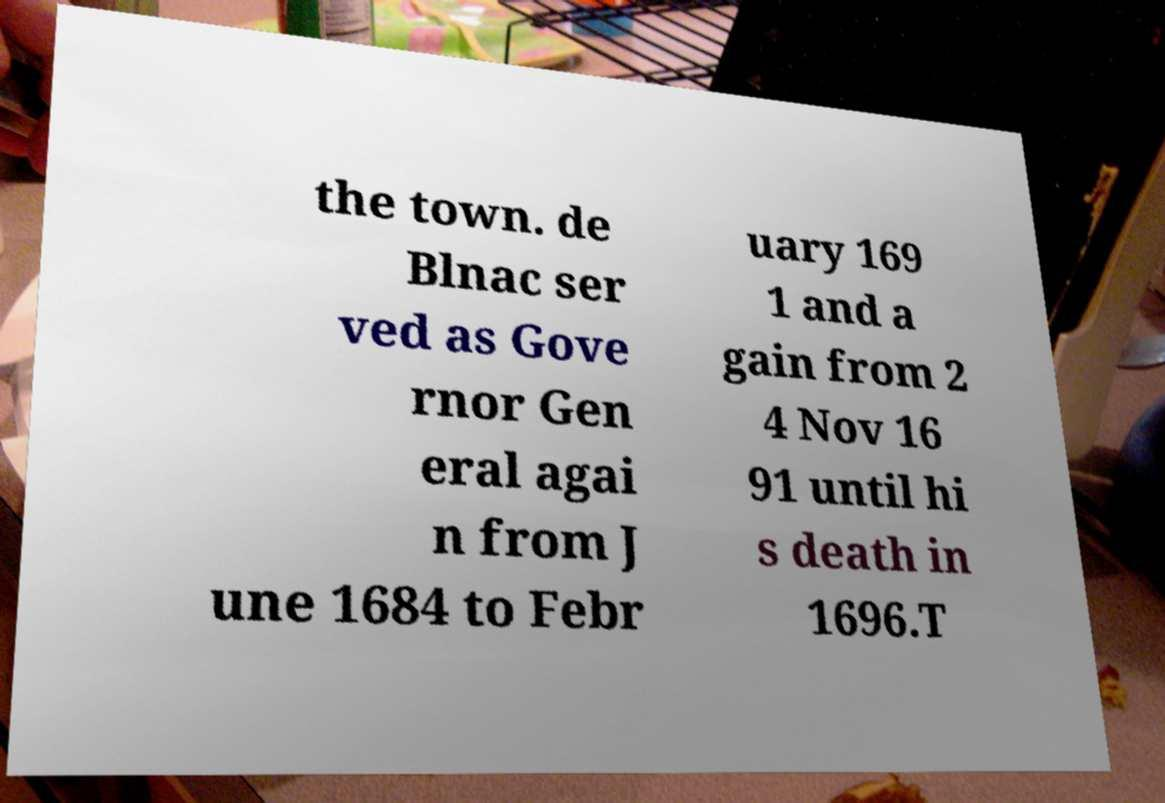Please read and relay the text visible in this image. What does it say? the town. de Blnac ser ved as Gove rnor Gen eral agai n from J une 1684 to Febr uary 169 1 and a gain from 2 4 Nov 16 91 until hi s death in 1696.T 